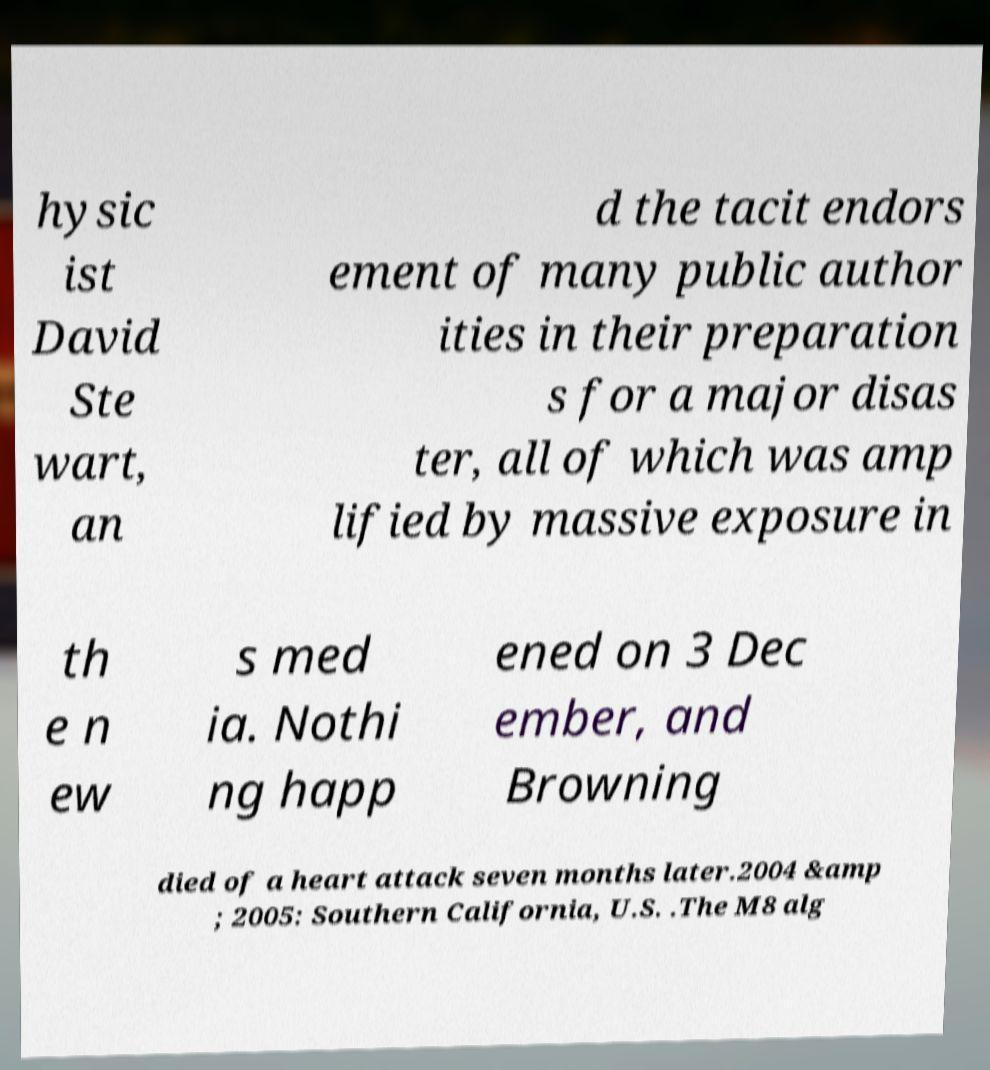I need the written content from this picture converted into text. Can you do that? hysic ist David Ste wart, an d the tacit endors ement of many public author ities in their preparation s for a major disas ter, all of which was amp lified by massive exposure in th e n ew s med ia. Nothi ng happ ened on 3 Dec ember, and Browning died of a heart attack seven months later.2004 &amp ; 2005: Southern California, U.S. .The M8 alg 